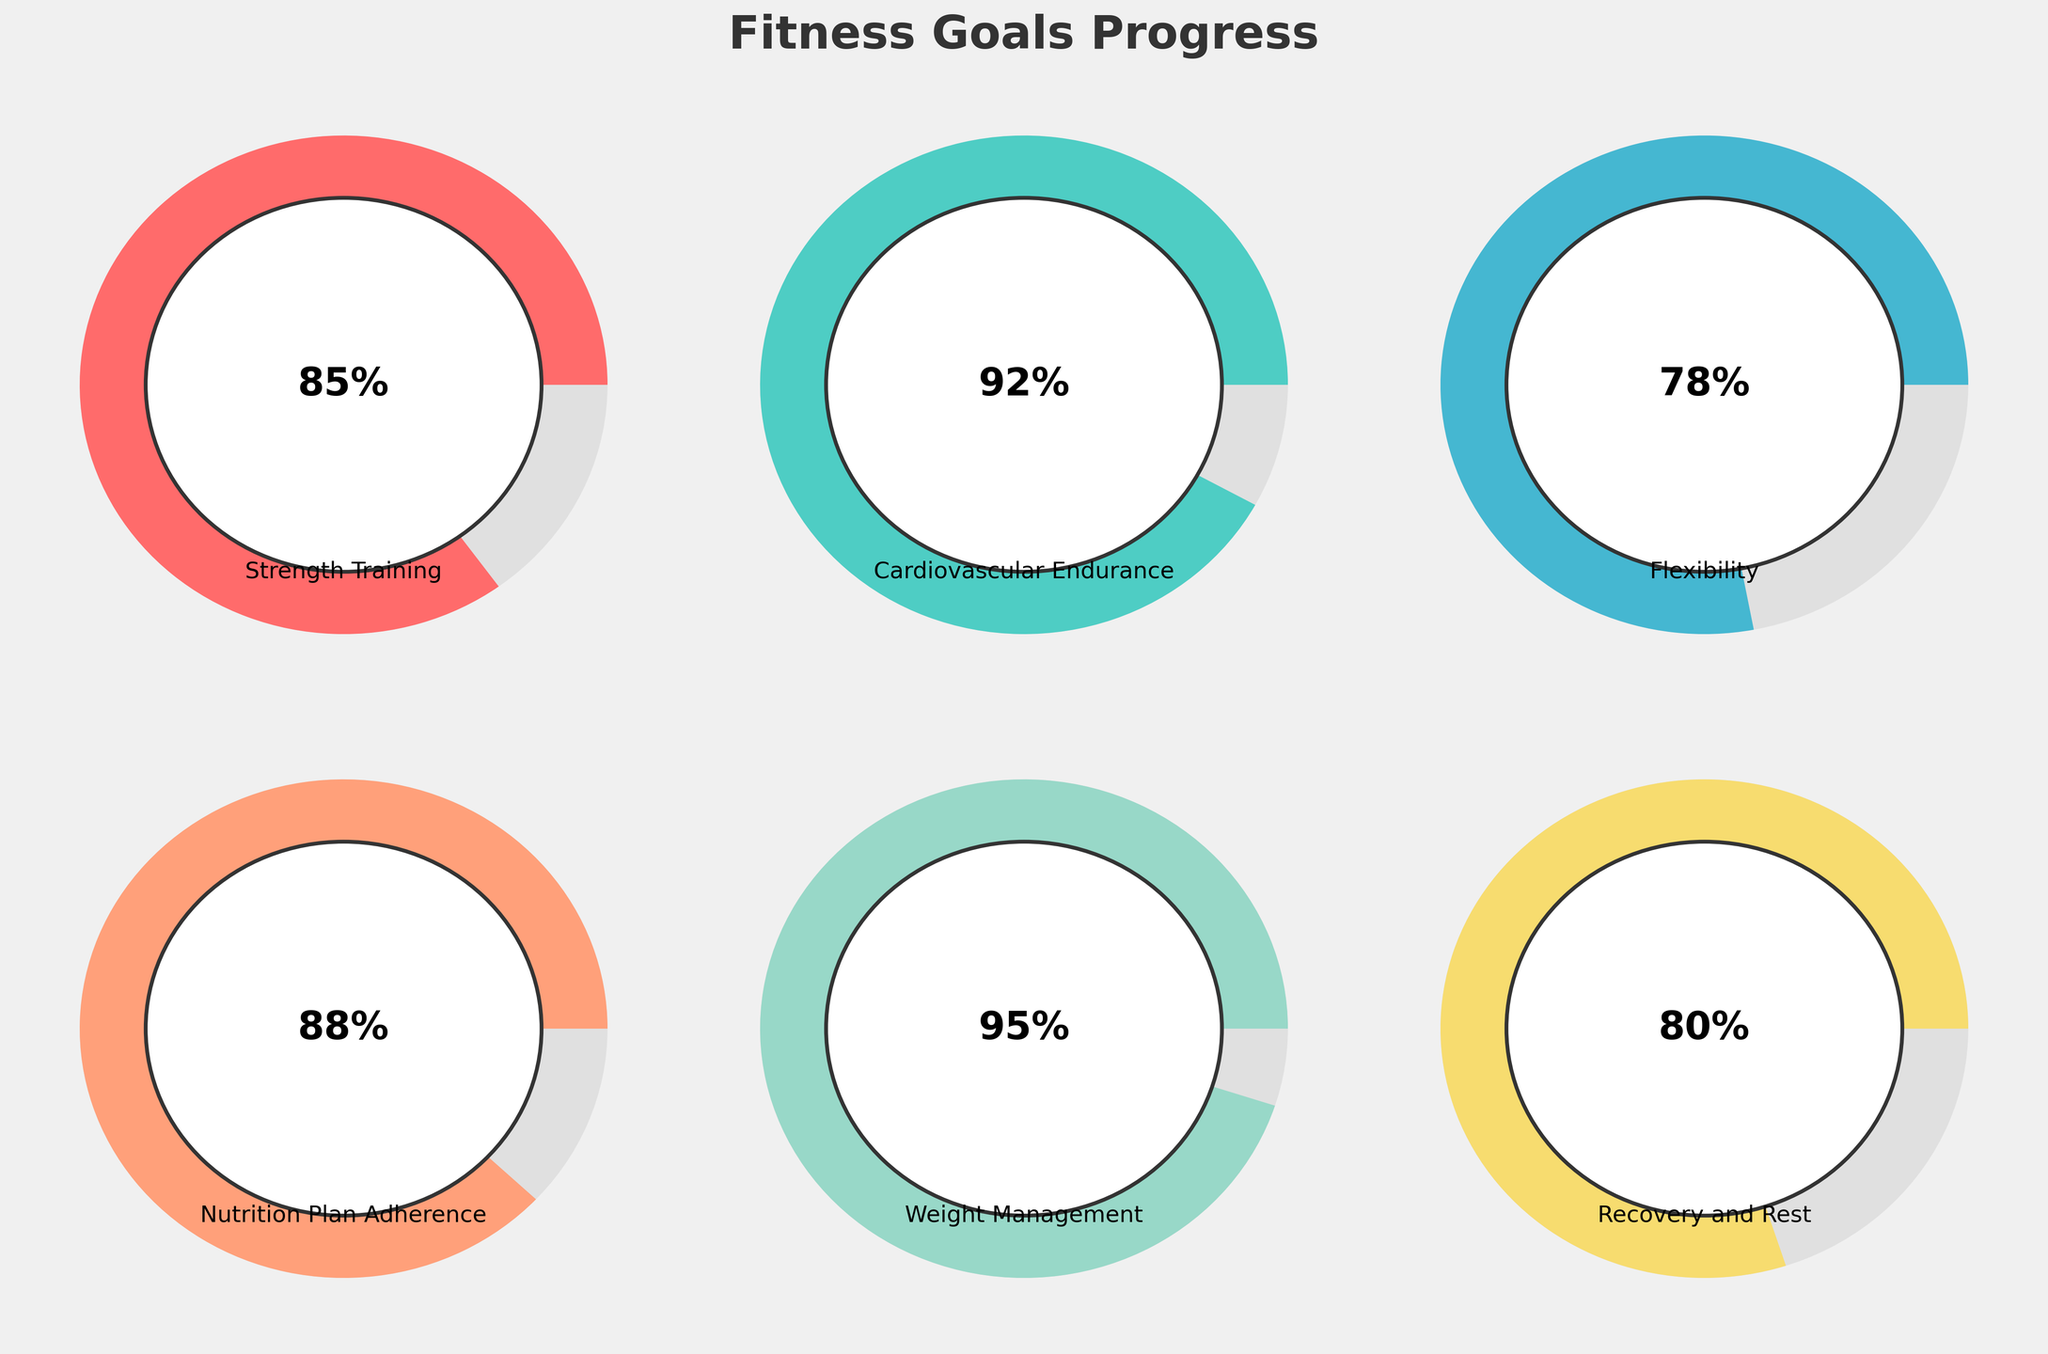Which fitness category has the highest progress percentage? By examining each gauge chart's progress percentage displayed in the center of the circle, Cardiovascular Endurance shows 92%, which is the highest among all categories.
Answer: Cardiovascular Endurance What is the average progress percentage across all fitness categories? Sum the progress percentages of all categories: (85 + 92 + 78 + 88 + 95 + 80) = 518. Then divide by the number of categories (6): 518 / 6 = 86.33.
Answer: 86.33% Which fitness category has the lowest progress percentage? By looking at all the progress percentages displayed in the gauge charts, Flexibility has the lowest at 78%.
Answer: Flexibility Are there any categories with progress percentages above 90%? If so, which ones? Check each gauge chart for any percentages above 90%. Both Cardiovascular Endurance (92%) and Weight Management (95%) are above 90%.
Answer: Cardiovascular Endurance and Weight Management How much higher is the progress percentage of Weight Management compared to Recovery and Rest? Subtract the progress percentage of Recovery and Rest (80%) from Weight Management (95%): 95 - 80 = 15.
Answer: 15 What is the total progress percentage when combining Strength Training and Nutrition Plan Adherence? Add the progress percentages of Strength Training (85%) and Nutrition Plan Adherence (88%): 85 + 88 = 173.
Answer: 173 Which two categories combined have the highest total progress percentage? Calculate the total progress percentages for each pair of categories and compare:
- Strength Training + Cardiovascular Endurance: 85 + 92 = 177
- Strength Training + Flexibility: 85 + 78 = 163
- Strength Training + Nutrition Plan Adherence: 85 + 88 = 173
- Strength Training + Weight Management: 85 + 95 = 180
- Strength Training + Recovery and Rest: 85 + 80 = 165
- Cardiovascular Endurance + Flexibility: 92 + 78 = 170
- Cardiovascular Endurance + Nutrition Plan Adherence: 92 + 88 = 180
- Cardiovascular Endurance + Weight Management: 92 + 95 = 187
- Cardiovascular Endurance + Recovery and Rest: 92 + 80 = 172
- Flexibility + Nutrition Plan Adherence: 78 + 88 = 166
- Flexibility + Weight Management: 78 + 95 = 173
- Flexibility + Recovery and Rest: 78 + 80 = 158
- Nutrition Plan Adherence + Weight Management: 88 + 95 = 183
- Nutrition Plan Adherence + Recovery and Rest: 88 + 80 = 168
- Weight Management + Recovery and Rest: 95 + 80 = 175
Cardiovascular Endurance and Weight Management have the highest combined total at 187.
Answer: Cardiovascular Endurance and Weight Management 